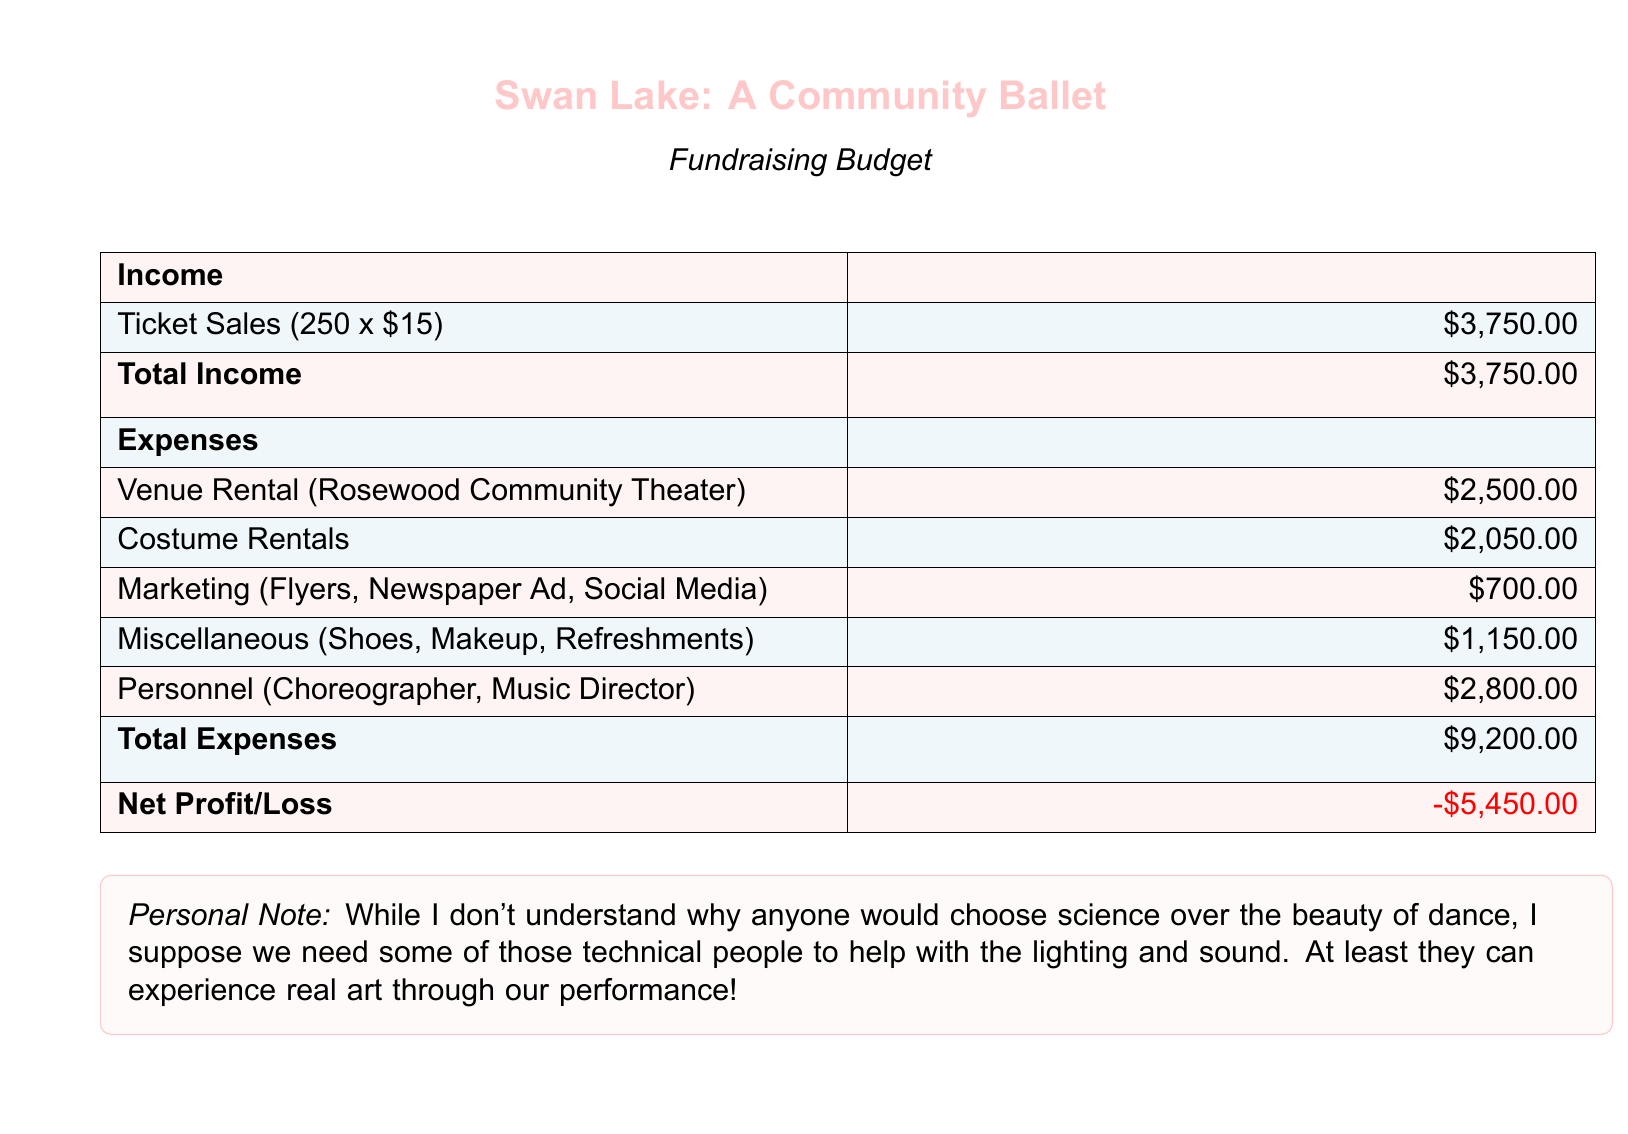What is the total income? The total income is directly provided in the document as a single sum of all income sources, calculated from ticket sales.
Answer: $3,750.00 What is the venue rental cost? The venue rental cost is listed specifically in the expenses section of the document.
Answer: $2,500.00 How much are the costume rentals? The costume rentals amount is explicitly stated under the expenses section.
Answer: $2,050.00 What is the total expense amount? The total expense is calculated from all listed expenses in the budget document.
Answer: $9,200.00 What is the net profit or loss? The net profit or loss is summarized at the end of the budget and reflects the difference between total income and total expenses.
Answer: -$5,450.00 What marketing expenses are included? Marketing expenses are detailed as specific categories within the document, covering various promotional activities.
Answer: Flyers, Newspaper Ad, Social Media Who are included in the personnel costs? The personnel cost section specifies particular roles essential for the ballet performance.
Answer: Choreographer, Music Director What is the miscellaneous expense total? The miscellaneous expenses are indicated individually within the list of expenses.
Answer: $1,150.00 